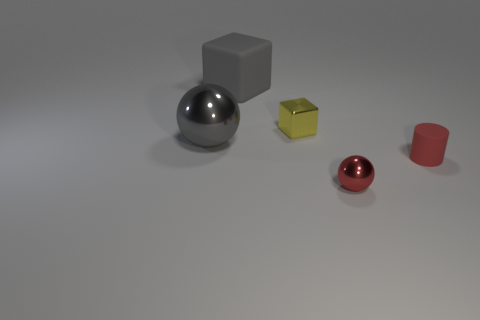Are there fewer tiny red rubber objects in front of the red shiny thing than big metallic objects on the left side of the gray cube?
Provide a succinct answer. Yes. How big is the red rubber thing?
Ensure brevity in your answer.  Small. How many large things are either gray objects or red spheres?
Your response must be concise. 2. There is a matte block; is it the same size as the matte object in front of the gray cube?
Your answer should be compact. No. Are there any other things that are the same shape as the tiny red rubber object?
Your answer should be compact. No. What number of large green metallic blocks are there?
Keep it short and to the point. 0. What number of red things are either cylinders or metal blocks?
Offer a terse response. 1. Is the gray thing on the right side of the big sphere made of the same material as the tiny red cylinder?
Offer a terse response. Yes. How many other things are the same material as the big block?
Ensure brevity in your answer.  1. What is the red sphere made of?
Offer a very short reply. Metal. 